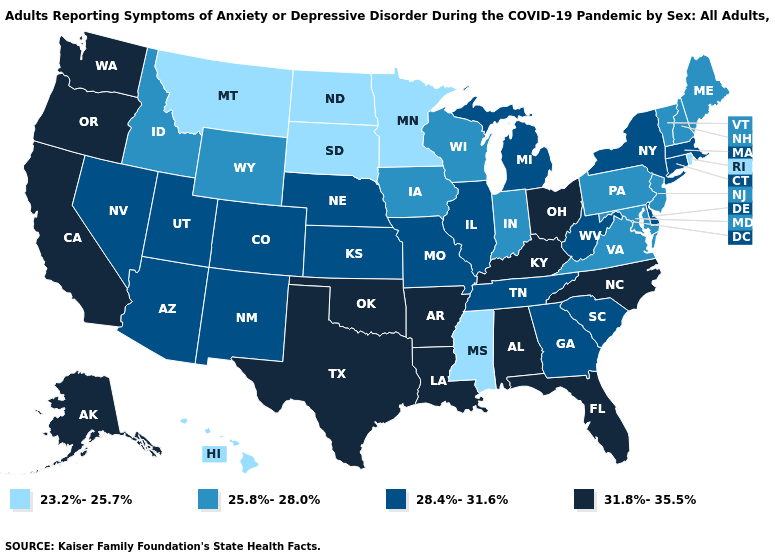Name the states that have a value in the range 25.8%-28.0%?
Short answer required. Idaho, Indiana, Iowa, Maine, Maryland, New Hampshire, New Jersey, Pennsylvania, Vermont, Virginia, Wisconsin, Wyoming. What is the highest value in states that border Tennessee?
Be succinct. 31.8%-35.5%. Name the states that have a value in the range 23.2%-25.7%?
Write a very short answer. Hawaii, Minnesota, Mississippi, Montana, North Dakota, Rhode Island, South Dakota. What is the lowest value in the USA?
Write a very short answer. 23.2%-25.7%. Does the first symbol in the legend represent the smallest category?
Concise answer only. Yes. What is the value of Florida?
Answer briefly. 31.8%-35.5%. Does Ohio have a lower value than Alaska?
Concise answer only. No. Does the map have missing data?
Be succinct. No. Name the states that have a value in the range 31.8%-35.5%?
Write a very short answer. Alabama, Alaska, Arkansas, California, Florida, Kentucky, Louisiana, North Carolina, Ohio, Oklahoma, Oregon, Texas, Washington. Does the first symbol in the legend represent the smallest category?
Quick response, please. Yes. Does Mississippi have the lowest value in the South?
Quick response, please. Yes. How many symbols are there in the legend?
Concise answer only. 4. What is the value of Illinois?
Short answer required. 28.4%-31.6%. Name the states that have a value in the range 28.4%-31.6%?
Be succinct. Arizona, Colorado, Connecticut, Delaware, Georgia, Illinois, Kansas, Massachusetts, Michigan, Missouri, Nebraska, Nevada, New Mexico, New York, South Carolina, Tennessee, Utah, West Virginia. What is the lowest value in the Northeast?
Write a very short answer. 23.2%-25.7%. 